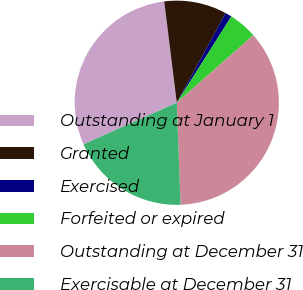<chart> <loc_0><loc_0><loc_500><loc_500><pie_chart><fcel>Outstanding at January 1<fcel>Granted<fcel>Exercised<fcel>Forfeited or expired<fcel>Outstanding at December 31<fcel>Exercisable at December 31<nl><fcel>29.71%<fcel>9.91%<fcel>1.03%<fcel>4.52%<fcel>35.91%<fcel>18.92%<nl></chart> 